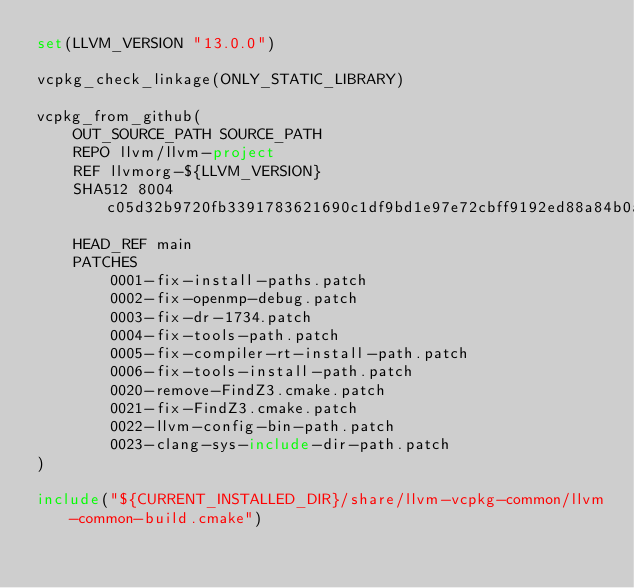<code> <loc_0><loc_0><loc_500><loc_500><_CMake_>set(LLVM_VERSION "13.0.0")

vcpkg_check_linkage(ONLY_STATIC_LIBRARY)

vcpkg_from_github(
    OUT_SOURCE_PATH SOURCE_PATH
    REPO llvm/llvm-project
    REF llvmorg-${LLVM_VERSION}
    SHA512 8004c05d32b9720fb3391783621690c1df9bd1e97e72cbff9192ed88a84b0acd303b61432145fa917b5b5e548c8cee29b24ef8547dcc8677adf4816e7a8a0eb2
    HEAD_REF main
    PATCHES
        0001-fix-install-paths.patch
        0002-fix-openmp-debug.patch
        0003-fix-dr-1734.patch
        0004-fix-tools-path.patch
        0005-fix-compiler-rt-install-path.patch
        0006-fix-tools-install-path.patch
        0020-remove-FindZ3.cmake.patch
        0021-fix-FindZ3.cmake.patch
        0022-llvm-config-bin-path.patch
        0023-clang-sys-include-dir-path.patch
)

include("${CURRENT_INSTALLED_DIR}/share/llvm-vcpkg-common/llvm-common-build.cmake")
</code> 